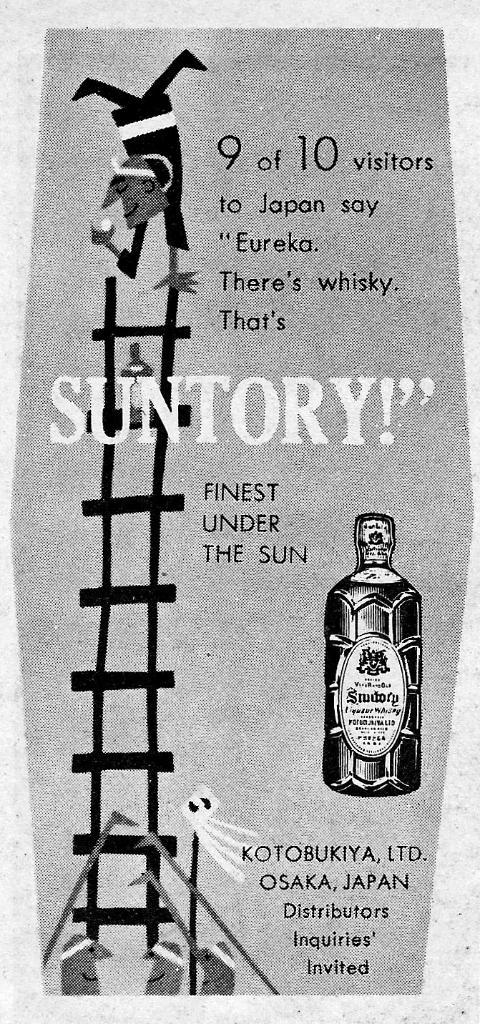<image>
Relay a brief, clear account of the picture shown. A black and white advertisement for a Japanese whisky called Suntory. 